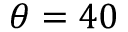Convert formula to latex. <formula><loc_0><loc_0><loc_500><loc_500>\theta = 4 0</formula> 